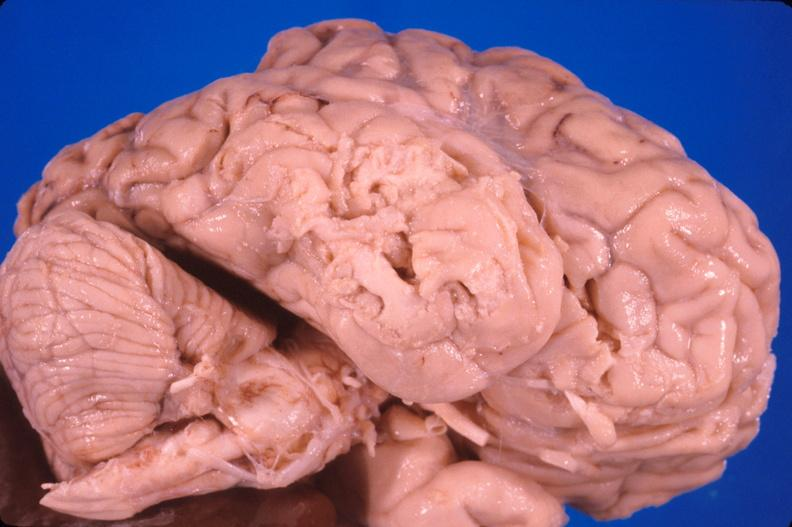what is present?
Answer the question using a single word or phrase. Nervous 